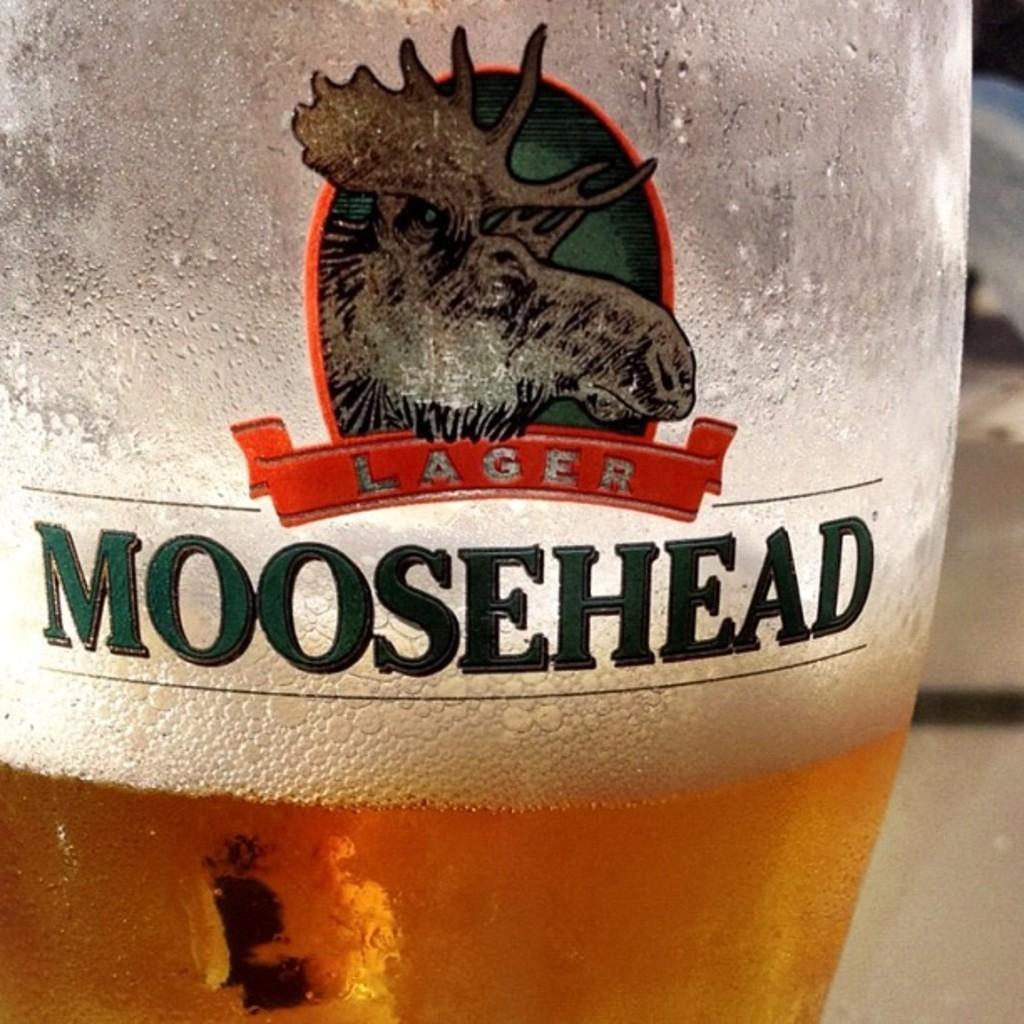Could you give a brief overview of what you see in this image? In this picture we can see a logo on the bottle and this is drink. 